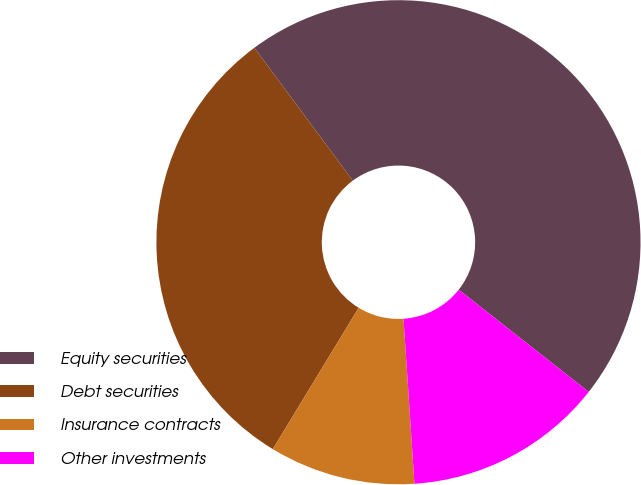<chart> <loc_0><loc_0><loc_500><loc_500><pie_chart><fcel>Equity securities<fcel>Debt securities<fcel>Insurance contracts<fcel>Other investments<nl><fcel>45.76%<fcel>31.16%<fcel>9.74%<fcel>13.34%<nl></chart> 